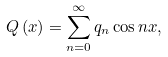Convert formula to latex. <formula><loc_0><loc_0><loc_500><loc_500>Q \left ( x \right ) = \sum _ { n = 0 } ^ { \infty } q _ { n } \cos n x ,</formula> 